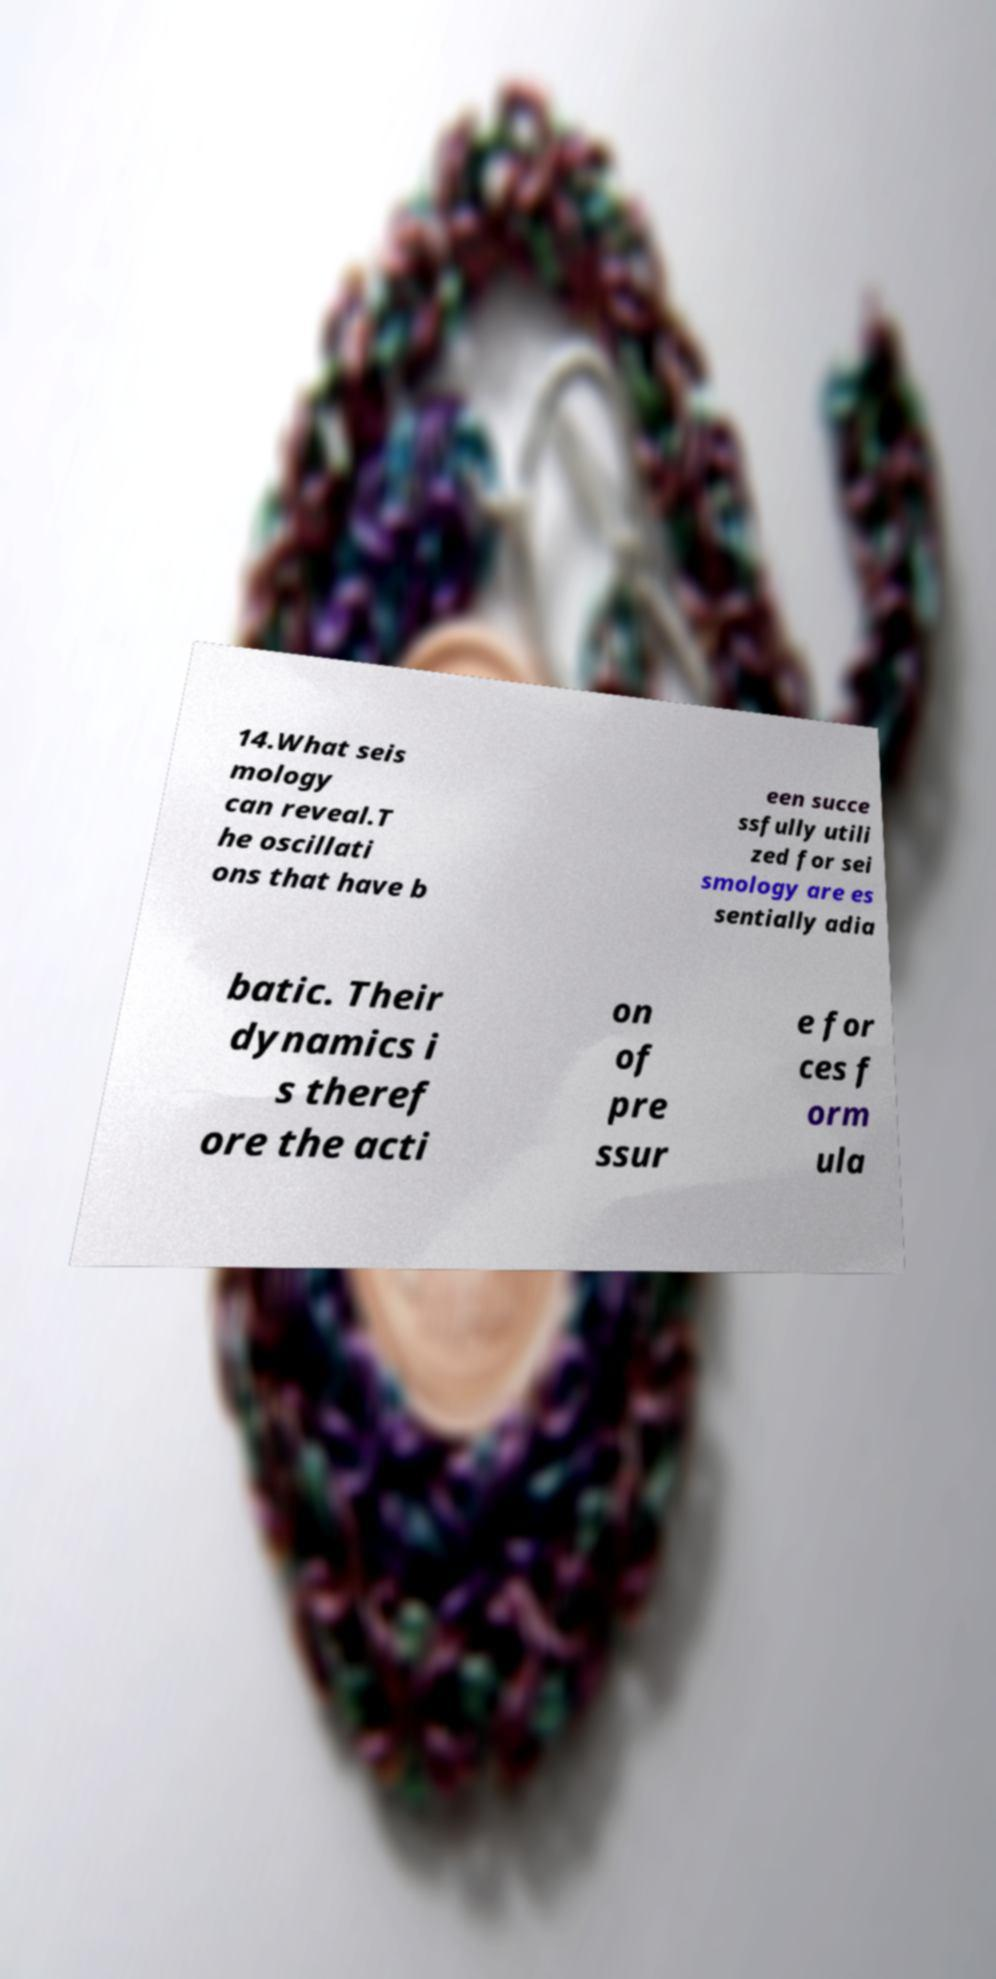Please identify and transcribe the text found in this image. 14.What seis mology can reveal.T he oscillati ons that have b een succe ssfully utili zed for sei smology are es sentially adia batic. Their dynamics i s theref ore the acti on of pre ssur e for ces f orm ula 